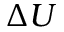<formula> <loc_0><loc_0><loc_500><loc_500>\Delta U</formula> 